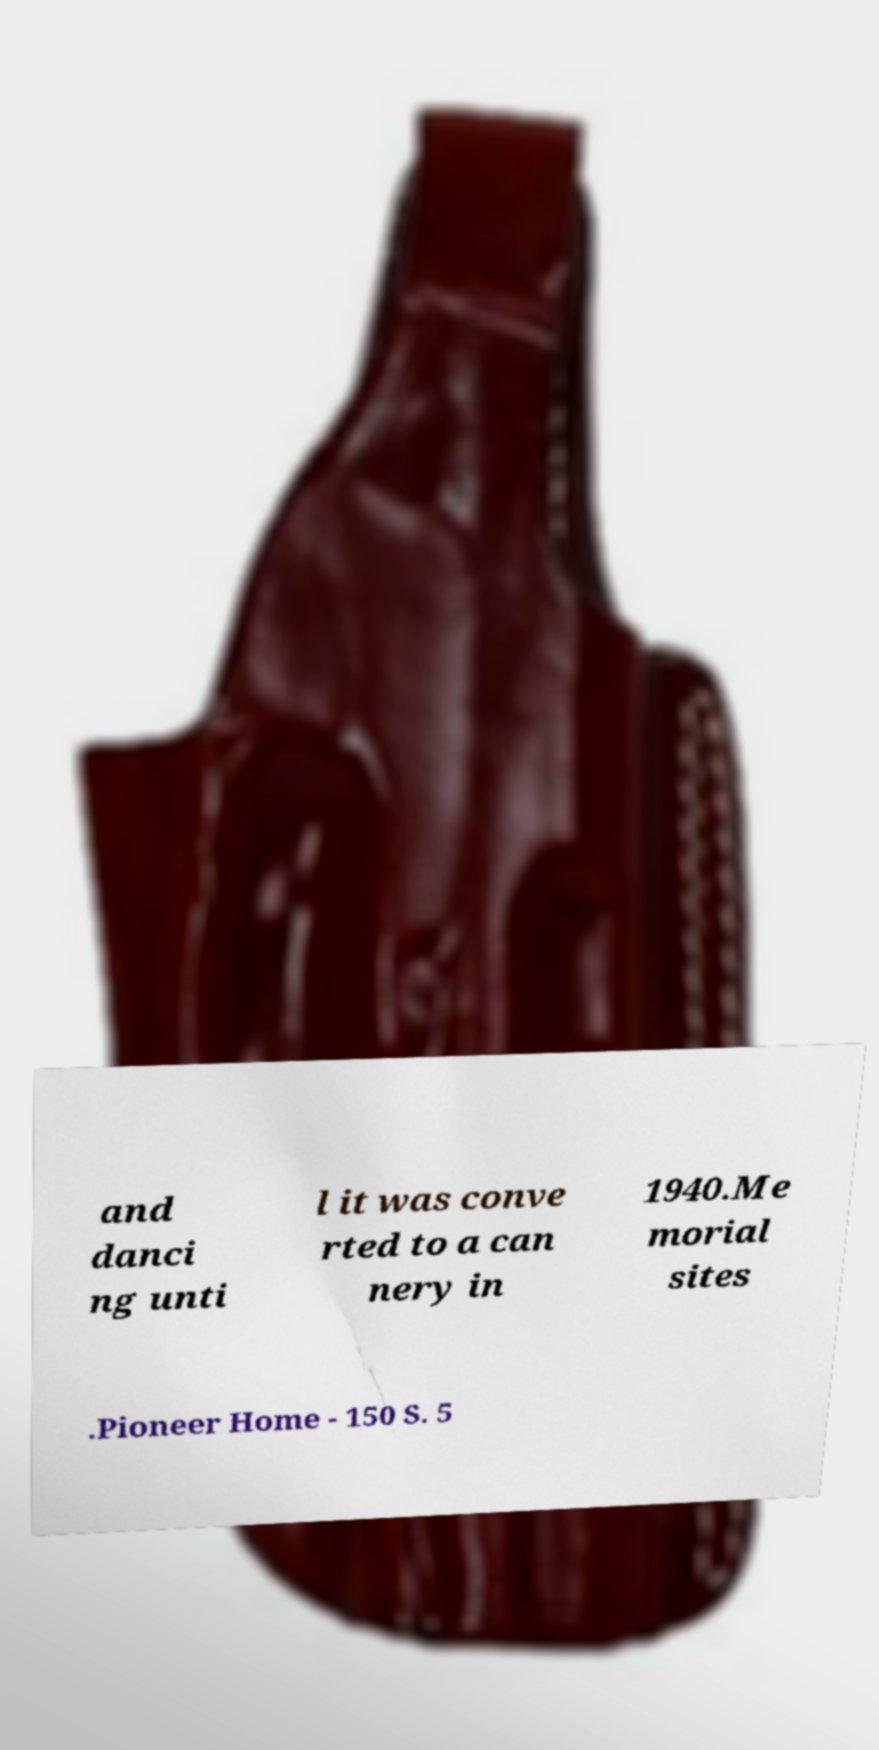What messages or text are displayed in this image? I need them in a readable, typed format. and danci ng unti l it was conve rted to a can nery in 1940.Me morial sites .Pioneer Home - 150 S. 5 